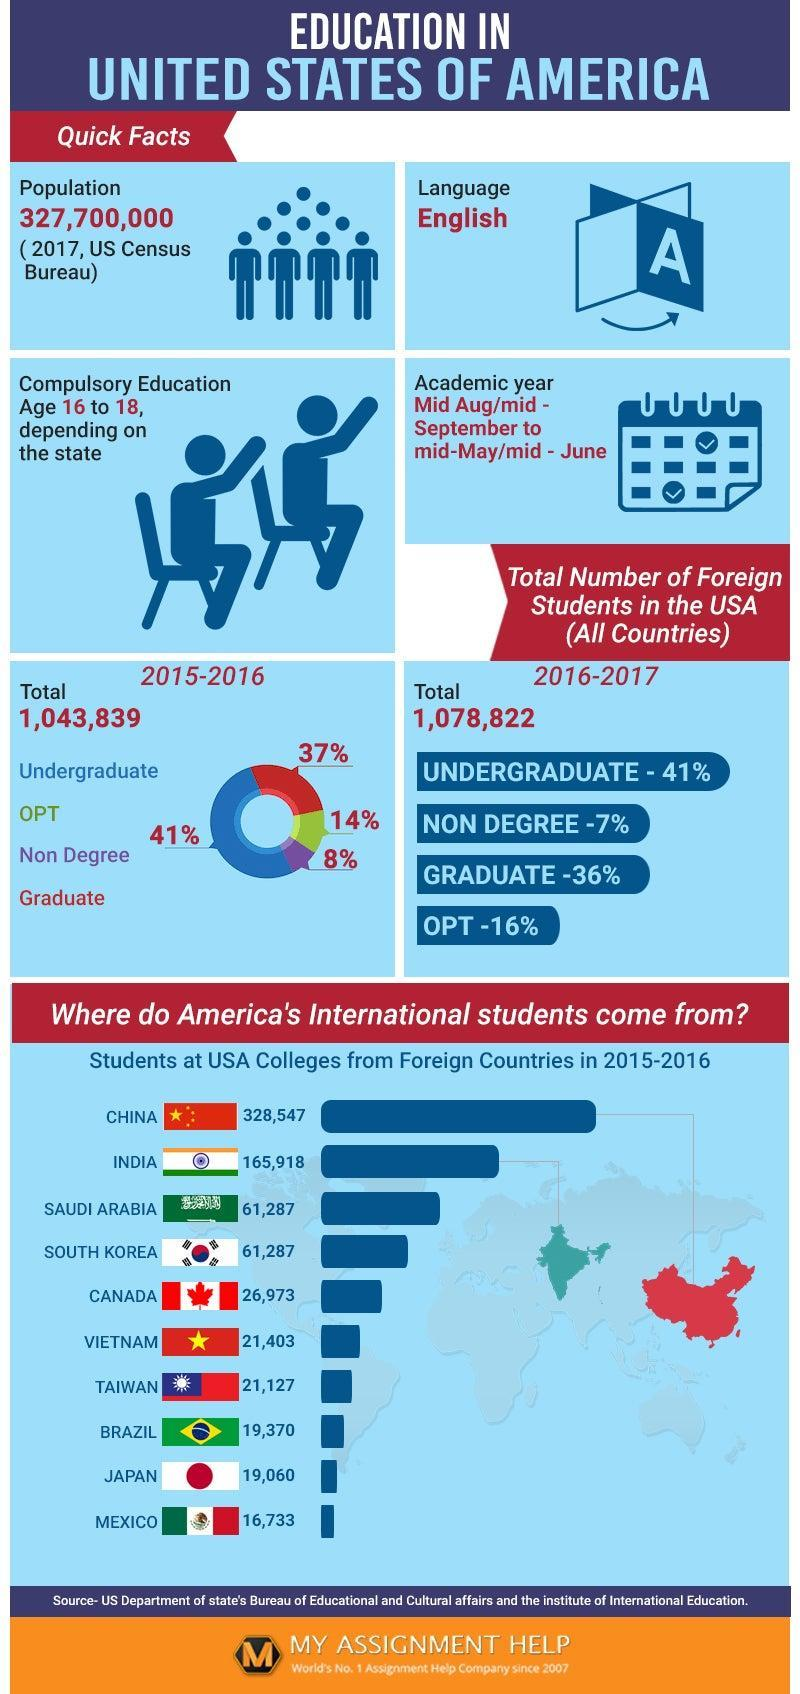which nation's flag have only one star in ther flag, china or vietnam?
Answer the question with a short phrase. vietnam which category of foreign students have the percentage of foreign students in the USA remained the same in both the acadamic years 2015-2016 and 2017-2017? undergraduate foreign students 